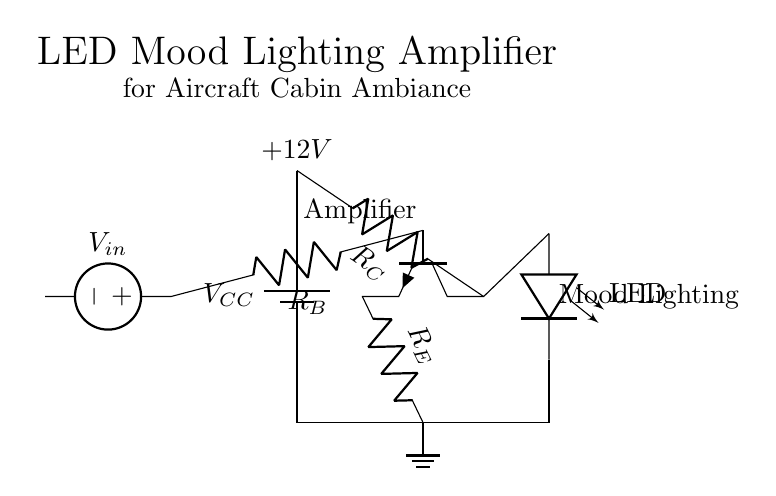What is the type of the transistor in this amplifier circuit? The transistor is represented as an NP transistor in the circuit diagram, which is indicated by the symbol and labeling used in the drawing.
Answer: NP What is the input voltage of the circuit? The input voltage is represented by the voltage source labeled V_in, which is connected to -4,2 in the circuit diagram. The specific value though is not provided; it denotes that a voltage is applied at that point.
Answer: V_in How many resistors are there in the circuit? The circuit includes three resistors, each connected to different parts of the transistor to form a proper biasing network. Analyzing the diagram, they are labeled as R_B, R_C, and R_E.
Answer: 3 What is the output component of this amplifier? The output component of the amplifier circuit is an LED, as indicated by the label next to the LED symbol and the connection from the collector of the transistor.
Answer: LED Explain the connection between the transistor and the LED. The collector of the transistor is connected directly to the LED, which means that when the transistor is activated by the input signal, it allows current to flow through the LED, lighting it up for mood ambiance. This relationship showcases the function of the amplifier in driving the LED.
Answer: Direct connection from collector to LED What is the purpose of resistor R_E in this circuit? Resistor R_E is used for emitter stabilization in the amplifier circuit. By providing feedback, it helps stabilize the operating point of the transistor and influences the gain, contributing to reliable performance, especially in varying conditions.
Answer: Emitter stabilization What does the "+" sign indicate in the amplifier circuit? The "+" sign next to the battery component indicates the positive terminal of the voltage supply, which connects to the power source, providing the necessary voltage for circuit operation.
Answer: Positive terminal 